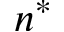<formula> <loc_0><loc_0><loc_500><loc_500>n ^ { * }</formula> 